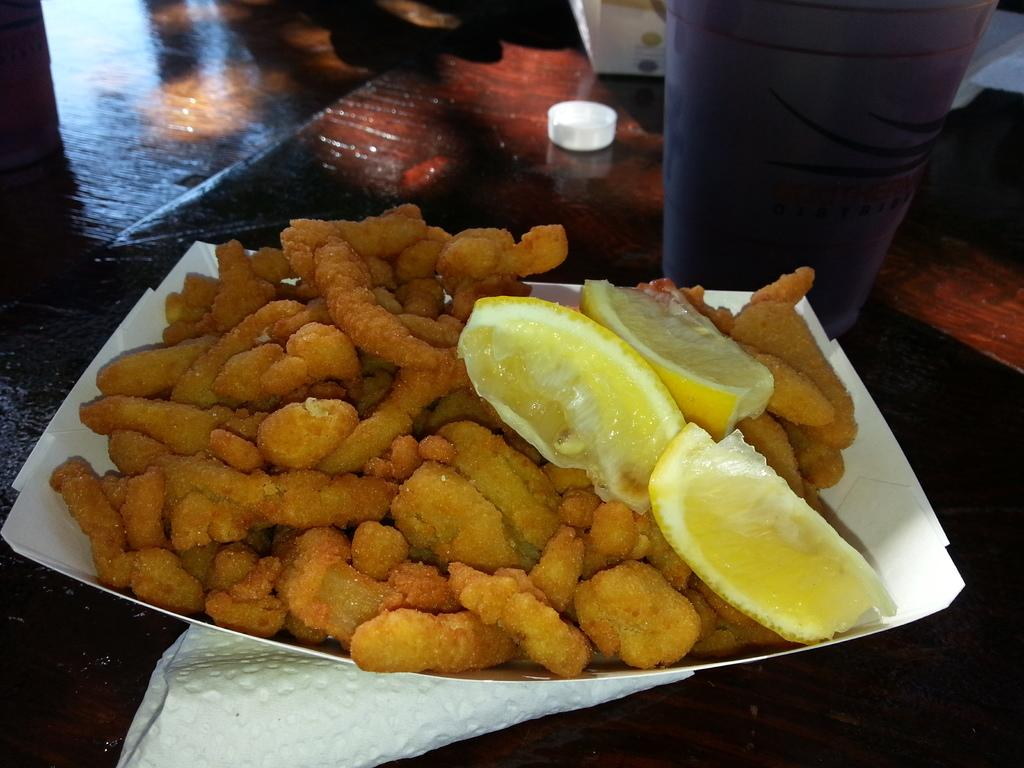What is present in the tray that is visible in the image? There are food items in a tray in the image. What can be used for cleaning or wiping in the image? Tissue papers are visible in the image. What type of surface is the tray and tissue papers placed on in the image? There are other objects on a wooden surface in the image. What type of crime is being committed in the image? There is no indication of any crime being committed in the image. Can you describe the harbor in the image? There is no harbor present in the image. 